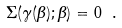<formula> <loc_0><loc_0><loc_500><loc_500>\Sigma ( \gamma ( \beta ) ; \beta ) = 0 \ .</formula> 